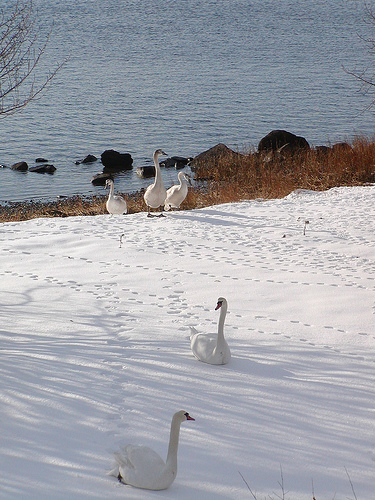<image>
Is the goose on the snow? Yes. Looking at the image, I can see the goose is positioned on top of the snow, with the snow providing support. Where is the bird in relation to the water? Is it in the water? No. The bird is not contained within the water. These objects have a different spatial relationship. 